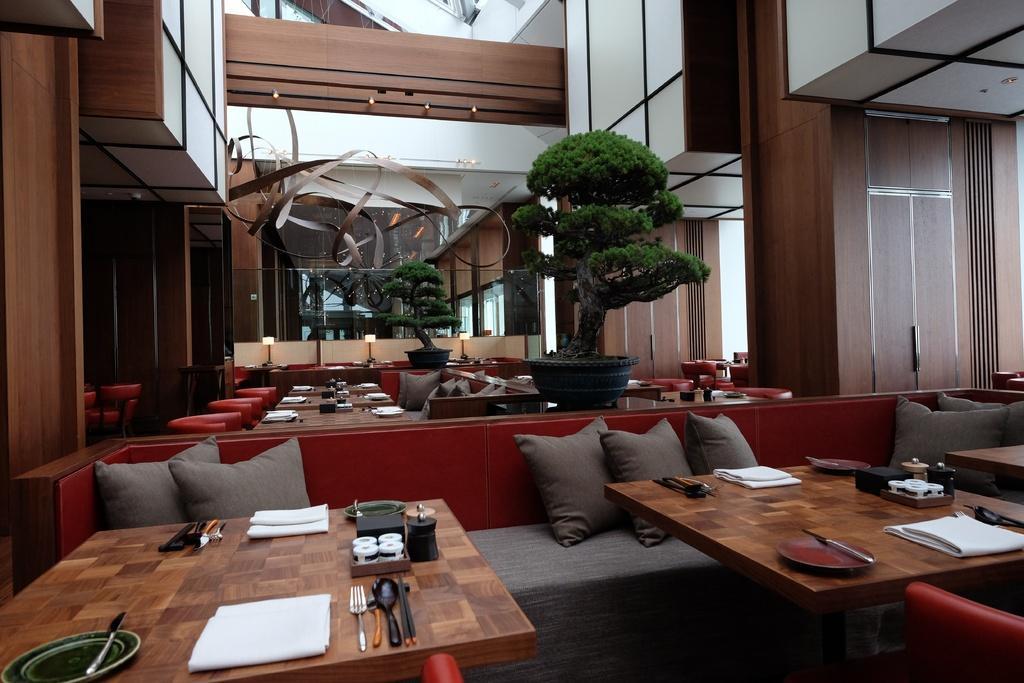Please provide a concise description of this image. This is a picture of a restaurant or a hotel. In the picture there are many tables, couches and houseplants, on the table there are plates, handkerchiefs, spoons and small jars. On the couches there are pillows and many chairs. In the top the building walls are made of wood. 